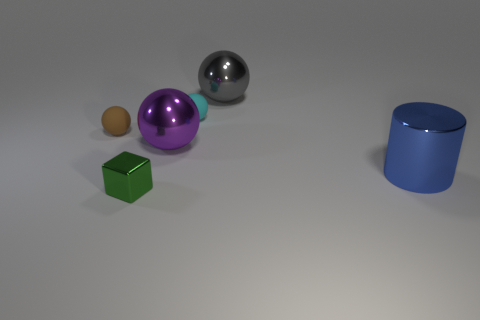What number of objects are either matte things that are on the right side of the big purple shiny sphere or large yellow spheres?
Your response must be concise. 1. There is a small sphere that is on the left side of the matte thing that is to the right of the tiny matte sphere on the left side of the small green thing; what is it made of?
Provide a succinct answer. Rubber. Are there more balls behind the cyan object than large blue objects that are to the left of the cylinder?
Your response must be concise. Yes. How many blocks are blue matte things or blue metal objects?
Your answer should be very brief. 0. How many tiny spheres are left of the rubber ball on the right side of the small thing that is in front of the blue metallic thing?
Your answer should be very brief. 1. Is the number of shiny spheres greater than the number of large purple things?
Your response must be concise. Yes. Is the size of the green metal object the same as the cyan matte sphere?
Ensure brevity in your answer.  Yes. How many things are cylinders or gray objects?
Provide a short and direct response. 2. The metallic thing to the right of the large object that is behind the small cyan matte object on the right side of the purple object is what shape?
Offer a terse response. Cylinder. Is the material of the small object on the right side of the green block the same as the ball to the left of the large purple ball?
Keep it short and to the point. Yes. 